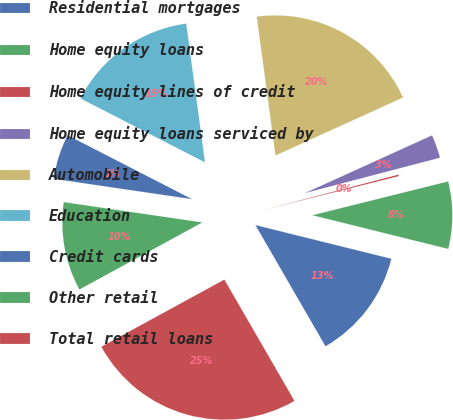Convert chart to OTSL. <chart><loc_0><loc_0><loc_500><loc_500><pie_chart><fcel>Residential mortgages<fcel>Home equity loans<fcel>Home equity lines of credit<fcel>Home equity loans serviced by<fcel>Automobile<fcel>Education<fcel>Credit cards<fcel>Other retail<fcel>Total retail loans<nl><fcel>12.79%<fcel>7.75%<fcel>0.19%<fcel>2.71%<fcel>20.35%<fcel>15.31%<fcel>5.23%<fcel>10.27%<fcel>25.39%<nl></chart> 